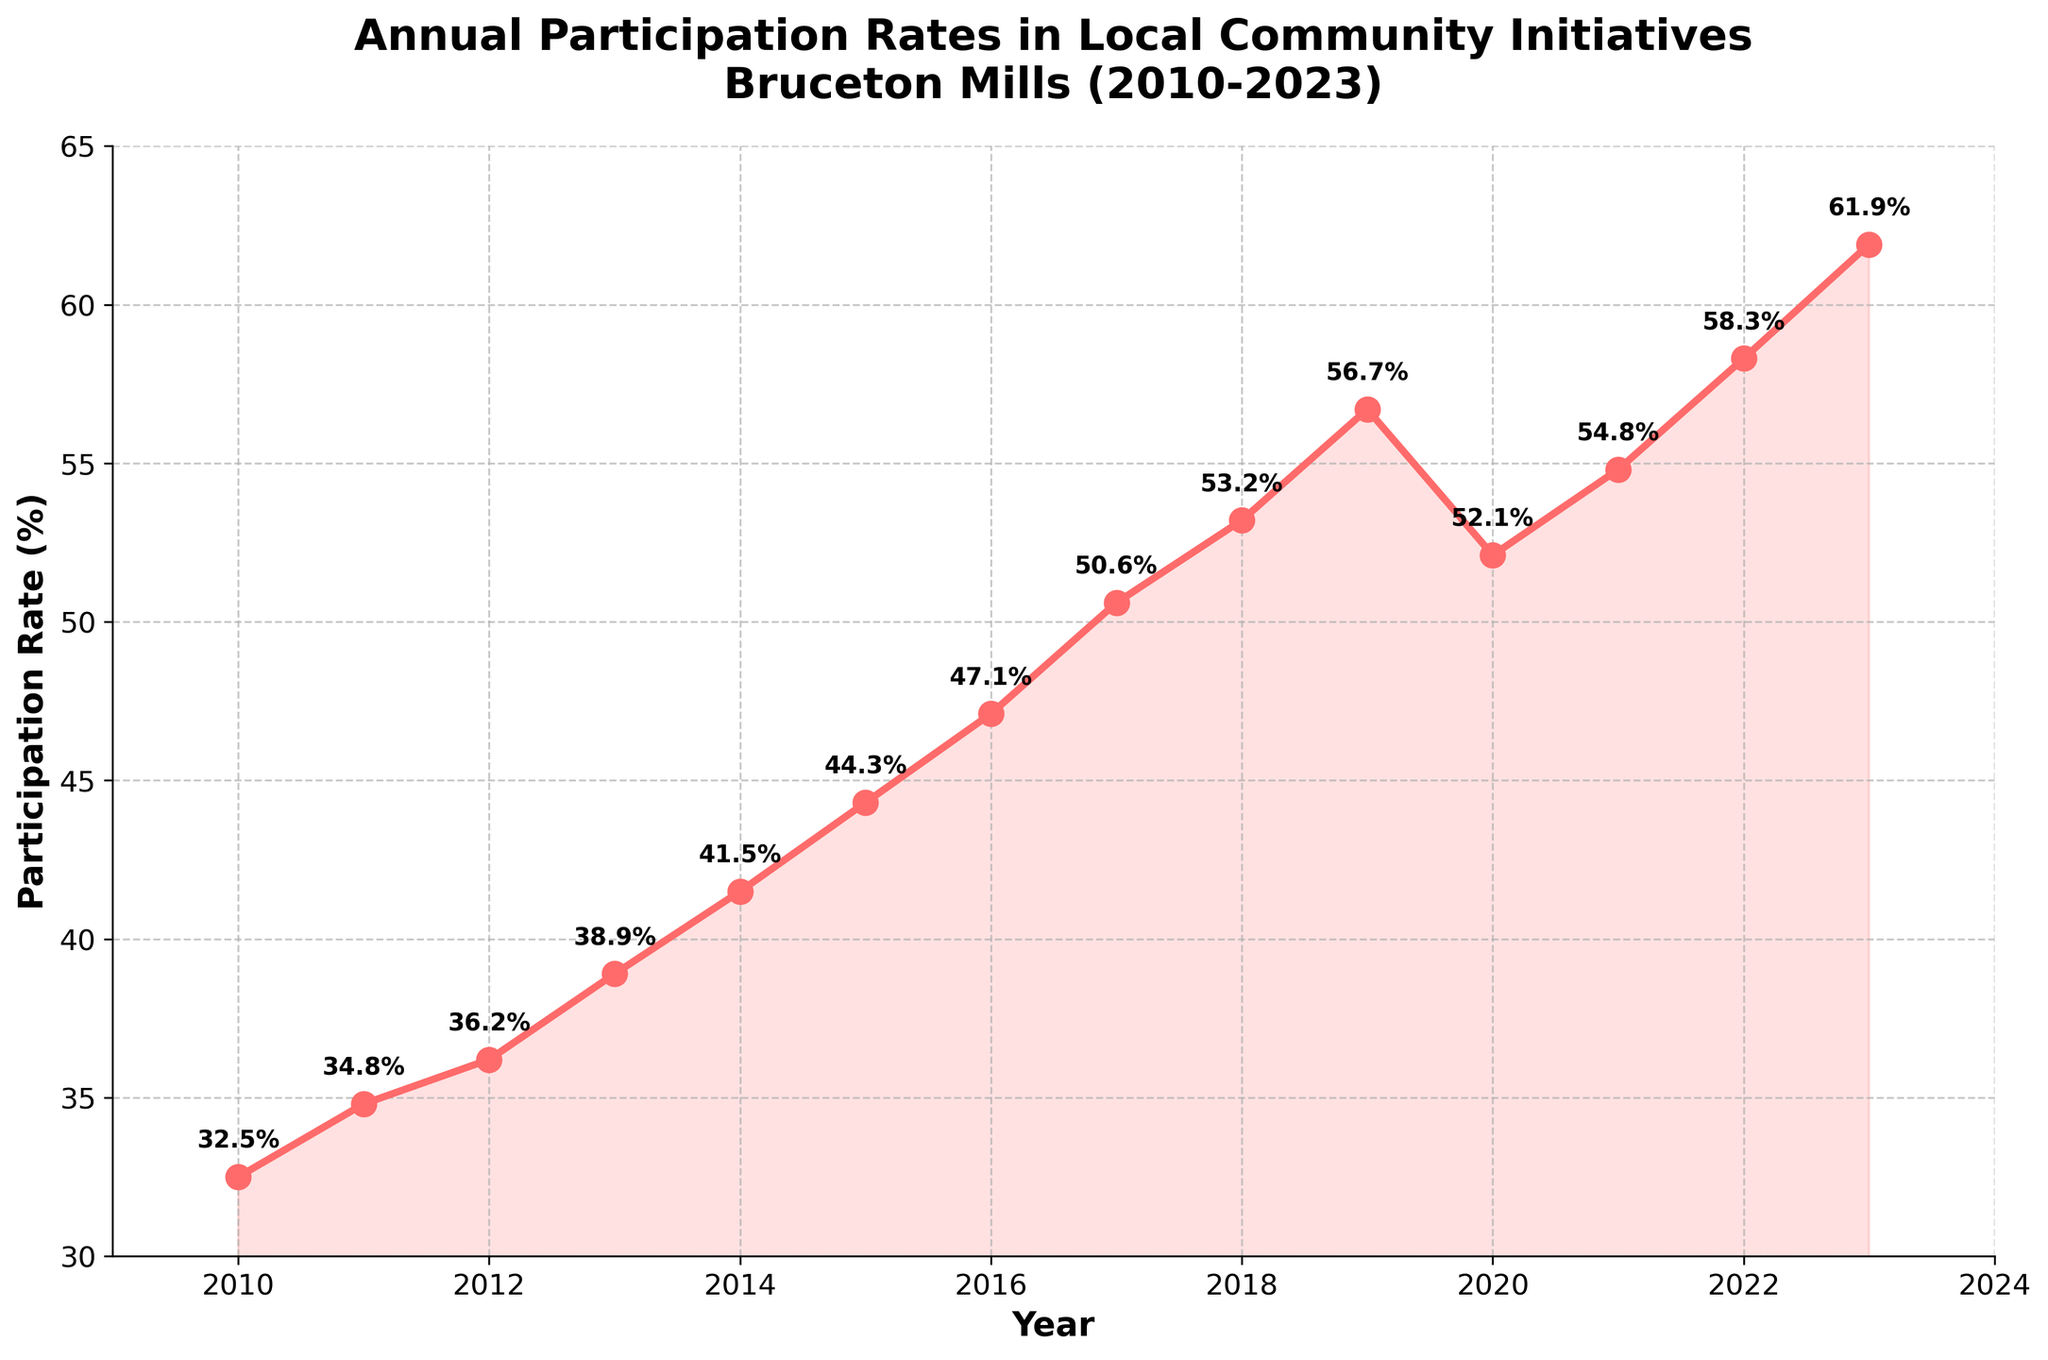What's the participation rate in 2018? The participation rate for 2018 can be directly read from the figure where the line marker for 2018 intersects the y-axis.
Answer: 53.2% What is the trend from 2010 to 2023? To determine the trend, observe the general direction of the line graph from 2010 to 2023. The line consistently rises from 2010 to 2019, dips in 2020, and then rises again up to 2023.
Answer: Increasing By how much did the participation rate increase from 2010 to 2023? Subtract the participation rate in 2010 from the rate in 2023: 61.9% - 32.5% = 29.4%.
Answer: 29.4% In which year did the participation rate drop, and by how much compared to the previous year? The drop is visible in 2020. The value in 2019 was 56.7%, and it dropped to 52.1% in 2020. So, 56.7% - 52.1% = 4.6%.
Answer: 2020, 4.6% What was the average participation rate between 2010 and 2023? Add all the annual participation rates from 2010 to 2023 and divide by the number of years (14): (32.5 + 34.8 + 36.2 + 38.9 + 41.5 + 44.3 + 47.1 + 50.6 + 53.2 + 56.7 + 52.1 + 54.8 + 58.3 + 61.9) / 14 = 47.23%.
Answer: 47.23% Between 2019 and 2023, in which year did the participation rate see the largest increase compared to the previous year? Compare annual increases: 
2019-2020: 52.1% - 56.7% = -4.6%; 
2020-2021: 54.8% - 52.1% = 2.7%; 
2021-2022: 58.3% - 54.8% = 3.5%; 
2022-2023: 61.9% - 58.3% = 3.6%.
The largest increase is from 2022 to 2023 with 3.6%.
Answer: 2022 to 2023 What color is used to represent the participation rate line? The color of the line can be seen as red in the figure.
Answer: Red Which year shows a participation rate closest to 50%? The closest to 50% can be seen in 2017 where the participation rate is 50.6%.
Answer: 2017 Calculate the median participation rate over the years shown in the figure. Sort the participation rates in ascending order and find the middle value(s). Median of (32.5, 34.8, 36.2, 38.9, 41.5, 44.3, 47.1, 50.6, 52.1, 53.2, 54.8, 56.7, 58.3, 61.9):
(44.3 + 47.1) / 2 = 45.7% since there are 14 values.
Answer: 45.7% What significant visual change can be observed between 2019 and 2020? The line graph shows a noticeable drop in participation rate between these years, indicating a decrease.
Answer: Drop in participation rate 